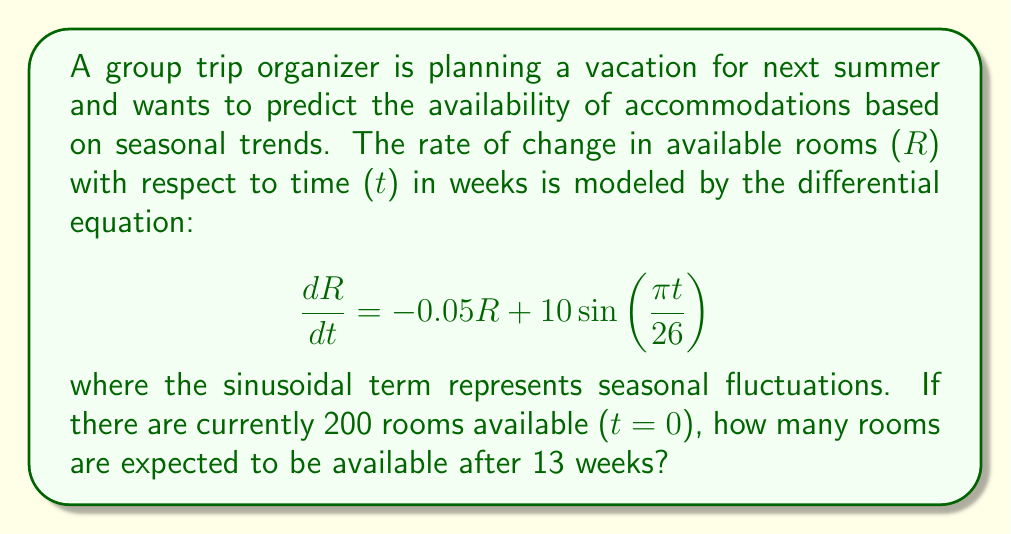Solve this math problem. To solve this problem, we need to use the method for solving first-order linear differential equations. The general form of the equation is:

$$\frac{dR}{dt} + P(t)R = Q(t)$$

In our case:
$P(t) = 0.05$ and $Q(t) = 10\sin(\frac{\pi t}{26})$

1) First, we find the integrating factor:
   $$\mu(t) = e^{\int P(t) dt} = e^{0.05t}$$

2) Multiply both sides of the original equation by the integrating factor:
   $$e^{0.05t}\frac{dR}{dt} + 0.05e^{0.05t}R = 10e^{0.05t}\sin(\frac{\pi t}{26})$$

3) The left side is now the derivative of $e^{0.05t}R$, so we can write:
   $$\frac{d}{dt}(e^{0.05t}R) = 10e^{0.05t}\sin(\frac{\pi t}{26})$$

4) Integrate both sides:
   $$e^{0.05t}R = \int 10e^{0.05t}\sin(\frac{\pi t}{26}) dt$$

5) The integral on the right side is complex, so we'll use the initial condition to avoid calculating it directly.

6) Let $C(t) = \int 10e^{0.05t}\sin(\frac{\pi t}{26}) dt$. Then the general solution is:
   $$R = e^{-0.05t}C(t)$$

7) Using the initial condition R(0) = 200:
   $$200 = C(0)$$

8) Therefore, the particular solution is:
   $$R = e^{-0.05t}(200 + C(t) - C(0))$$

9) After 13 weeks:
   $$R(13) = e^{-0.05(13)}(200 + C(13) - C(0))$$

10) We can approximate $C(13) - C(0)$ using numerical integration:
    $$C(13) - C(0) \approx 10 \int_0^{13} \sin(\frac{\pi t}{26}) dt = 10 \cdot \frac{26}{\pi} [1 - \cos(\frac{13\pi}{26})] \approx 82.8$$

11) Substituting this into our equation:
    $$R(13) = e^{-0.05(13)}(200 + 82.8) \approx 191.4$$
Answer: After 13 weeks, approximately 191 rooms are expected to be available. 